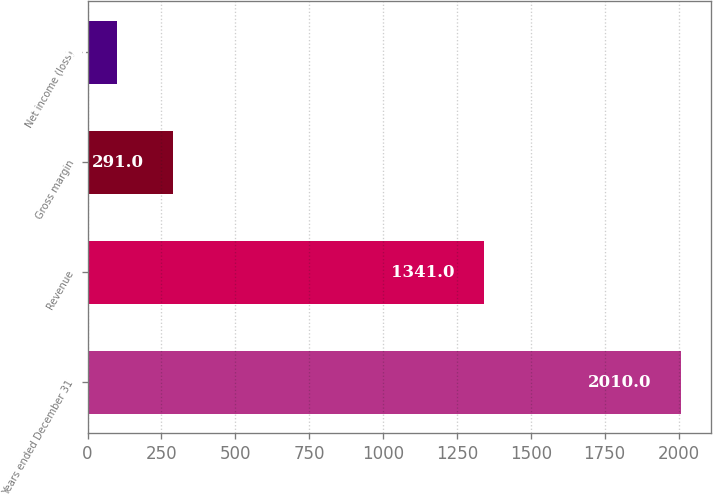Convert chart. <chart><loc_0><loc_0><loc_500><loc_500><bar_chart><fcel>Years ended December 31<fcel>Revenue<fcel>Gross margin<fcel>Net income (loss)<nl><fcel>2010<fcel>1341<fcel>291<fcel>100<nl></chart> 